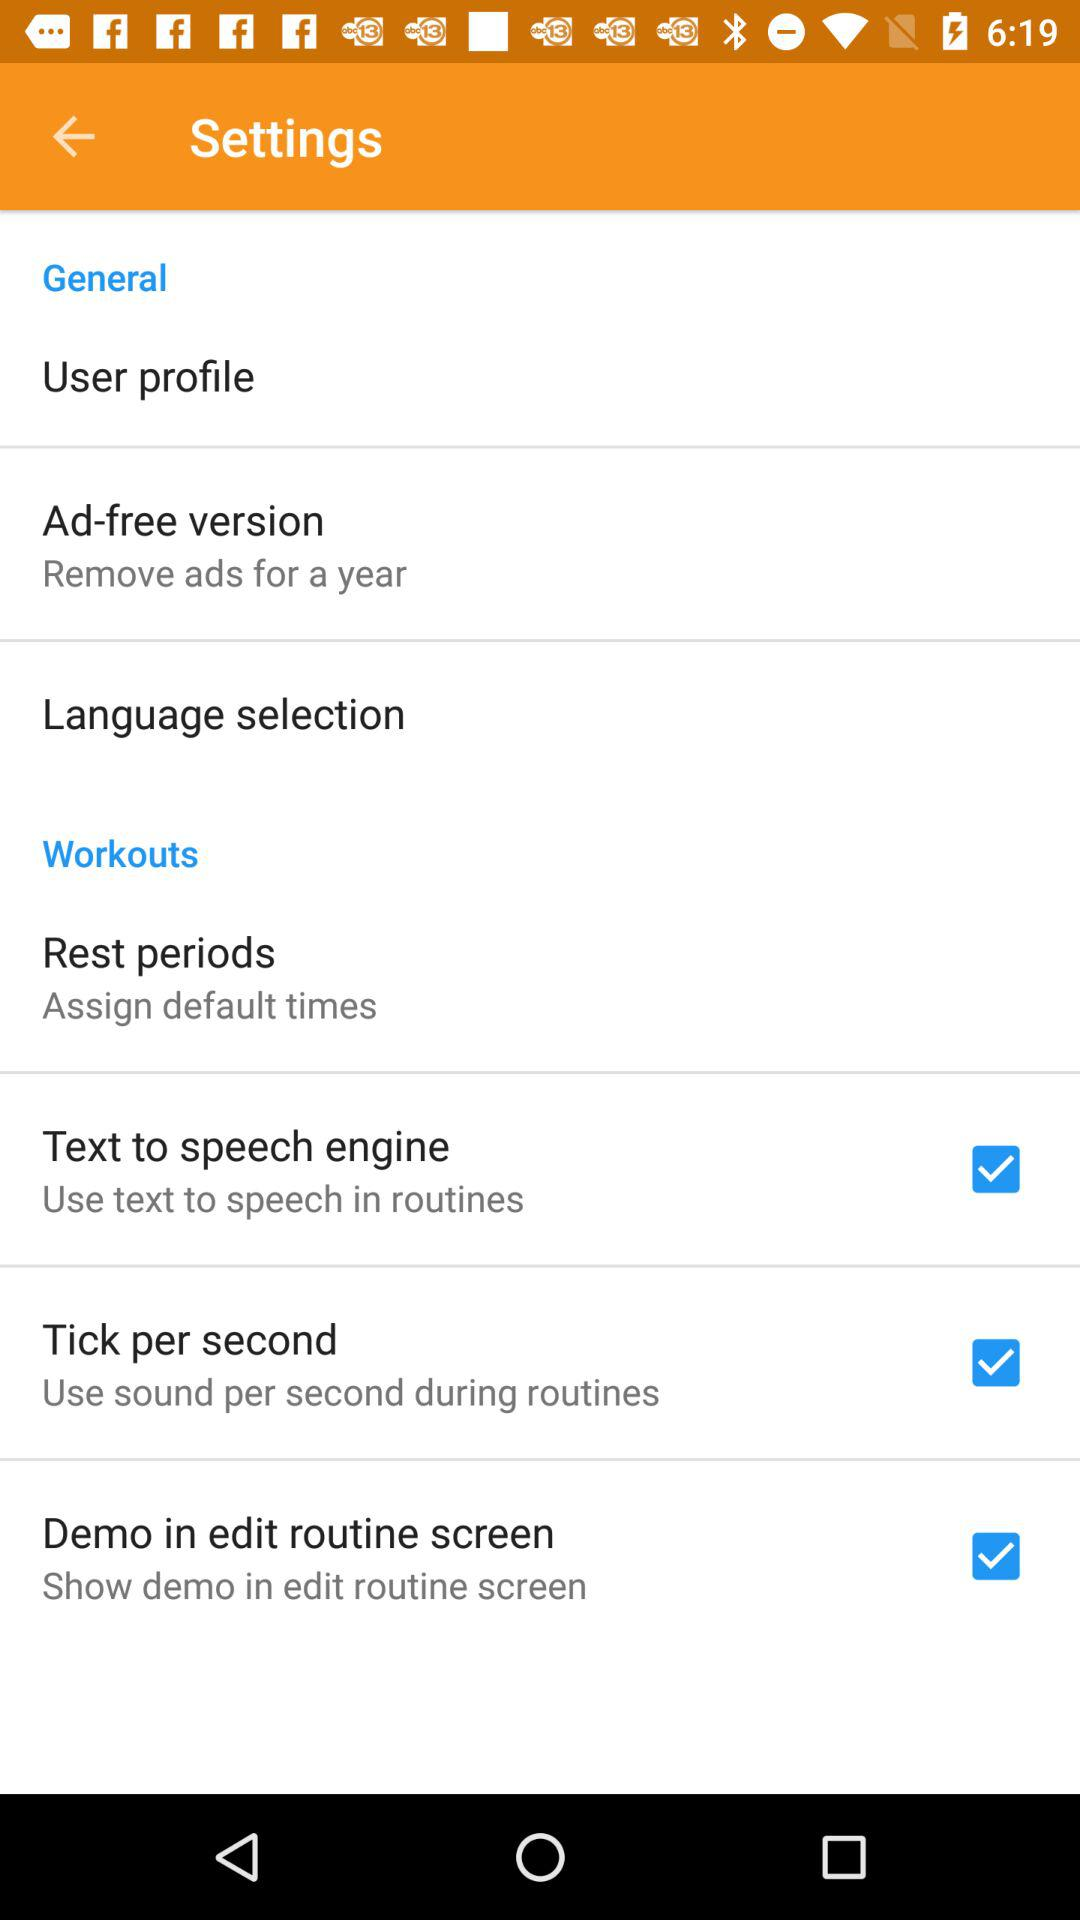How many items have a checkbox in the Settings screen?
Answer the question using a single word or phrase. 3 